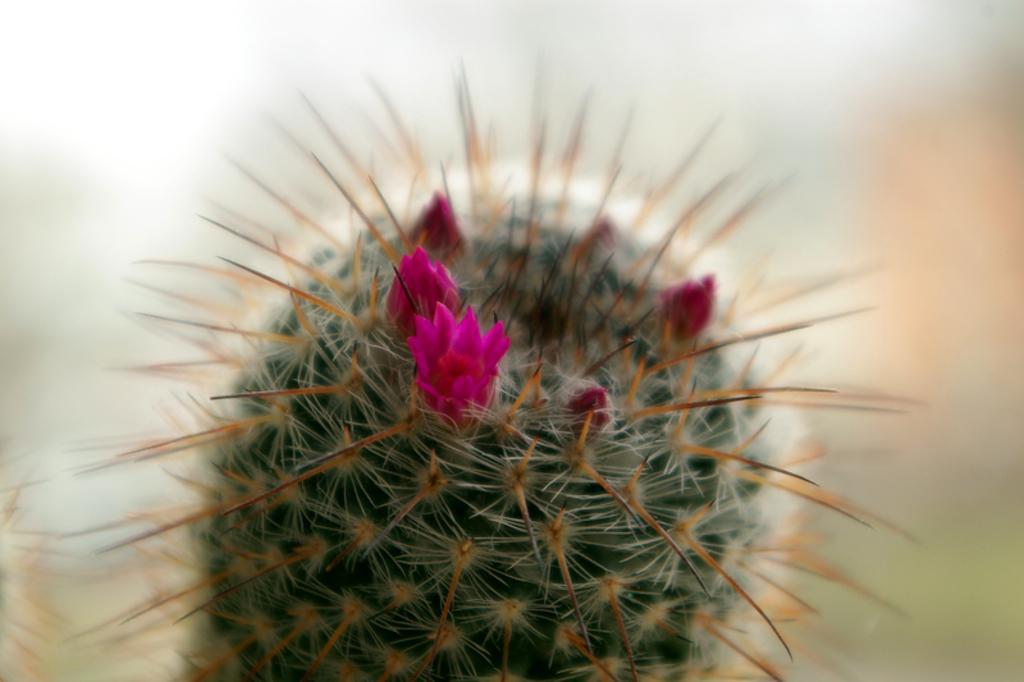Could you give a brief overview of what you see in this image? In the foreground of this image, there is a desert plant and to it, there is a flower and few buds. 